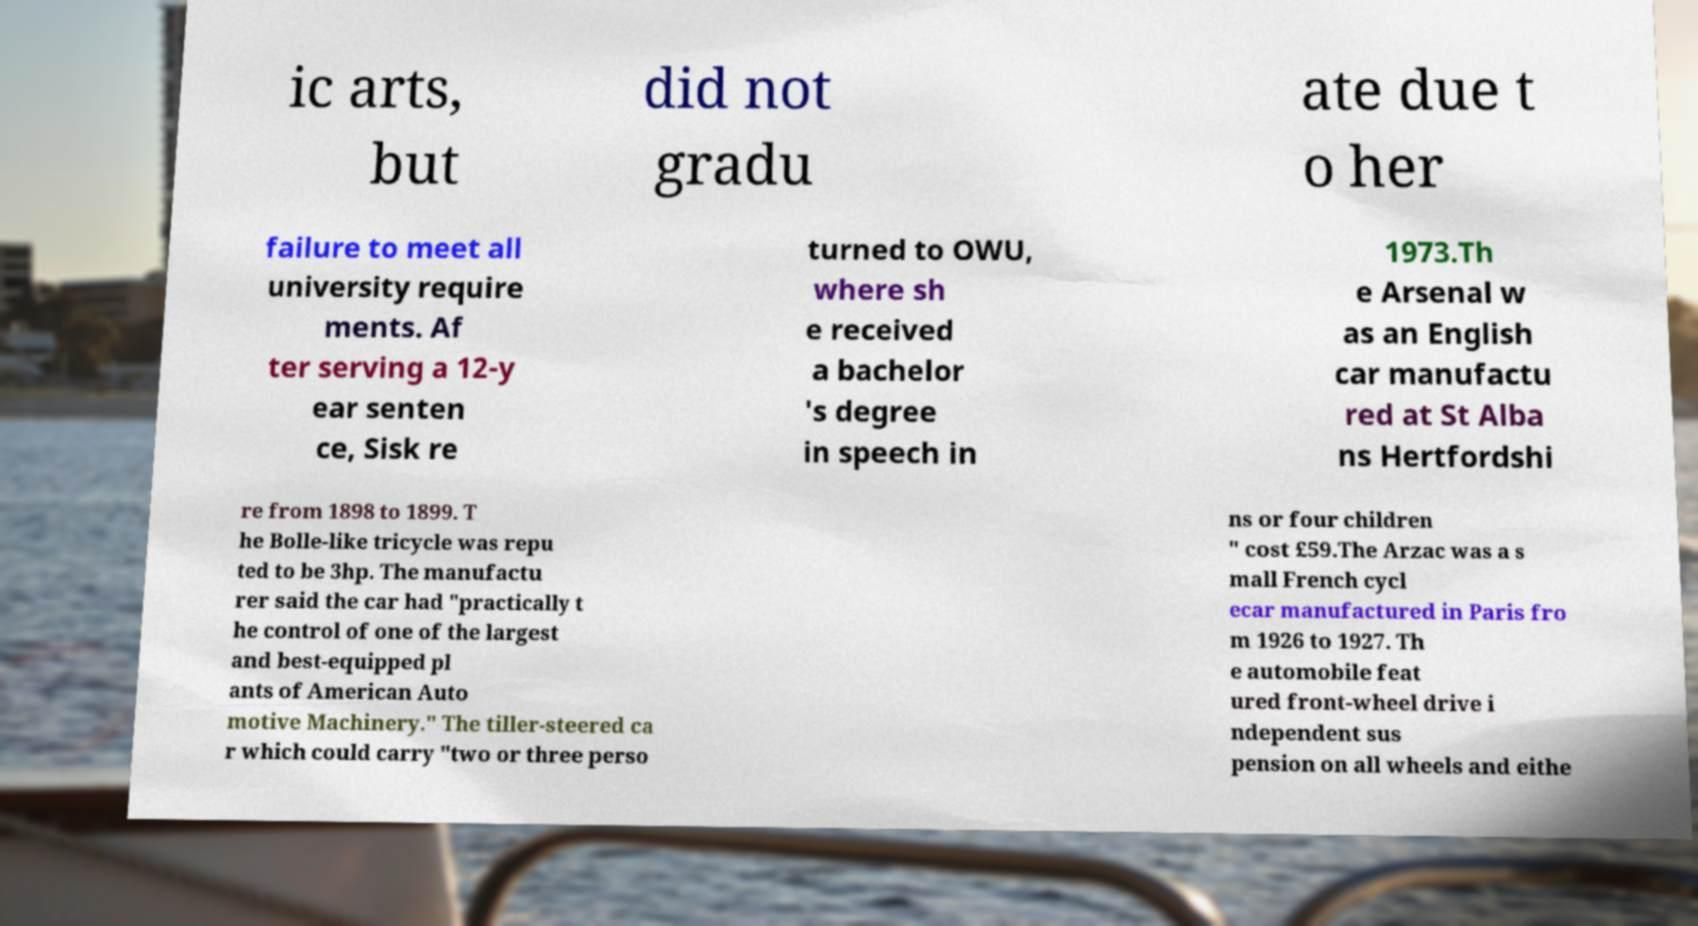For documentation purposes, I need the text within this image transcribed. Could you provide that? ic arts, but did not gradu ate due t o her failure to meet all university require ments. Af ter serving a 12-y ear senten ce, Sisk re turned to OWU, where sh e received a bachelor 's degree in speech in 1973.Th e Arsenal w as an English car manufactu red at St Alba ns Hertfordshi re from 1898 to 1899. T he Bolle-like tricycle was repu ted to be 3hp. The manufactu rer said the car had "practically t he control of one of the largest and best-equipped pl ants of American Auto motive Machinery." The tiller-steered ca r which could carry "two or three perso ns or four children " cost £59.The Arzac was a s mall French cycl ecar manufactured in Paris fro m 1926 to 1927. Th e automobile feat ured front-wheel drive i ndependent sus pension on all wheels and eithe 